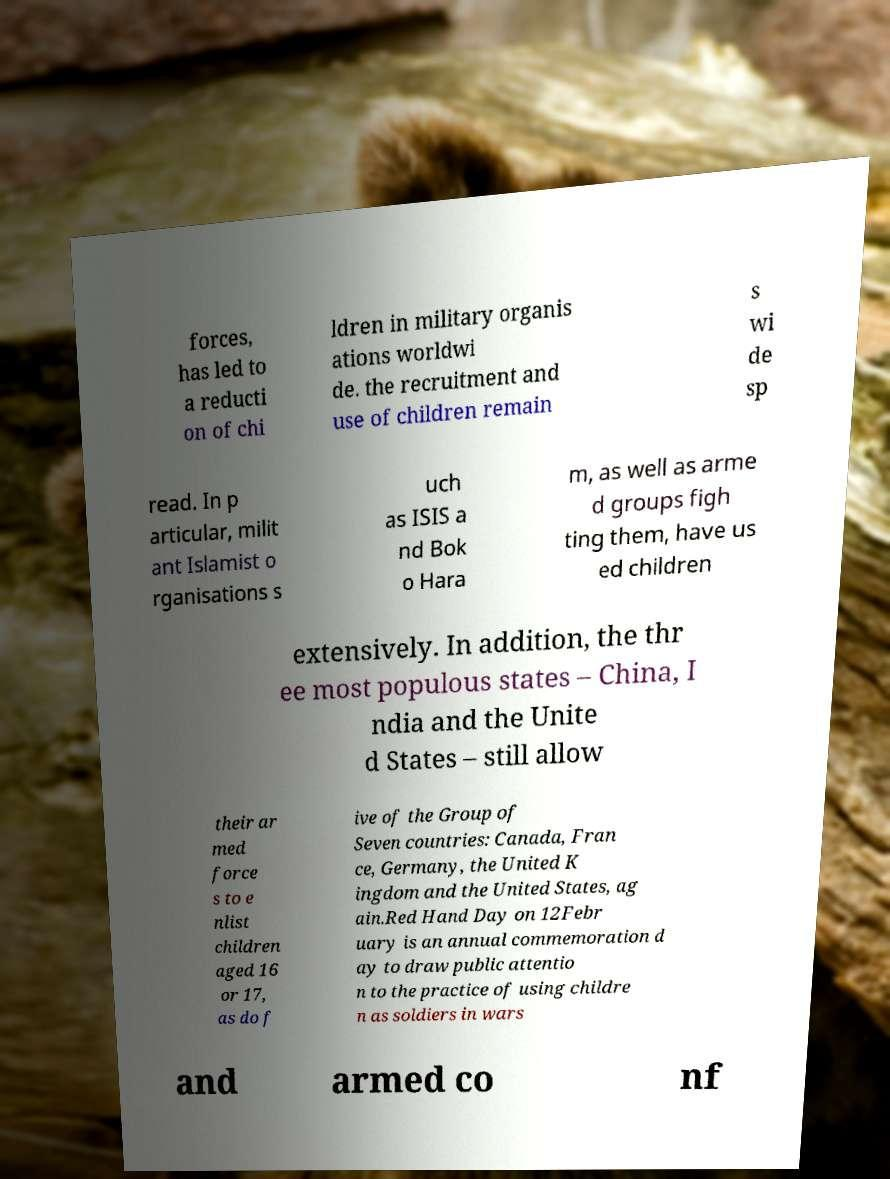Please read and relay the text visible in this image. What does it say? forces, has led to a reducti on of chi ldren in military organis ations worldwi de. the recruitment and use of children remain s wi de sp read. In p articular, milit ant Islamist o rganisations s uch as ISIS a nd Bok o Hara m, as well as arme d groups figh ting them, have us ed children extensively. In addition, the thr ee most populous states – China, I ndia and the Unite d States – still allow their ar med force s to e nlist children aged 16 or 17, as do f ive of the Group of Seven countries: Canada, Fran ce, Germany, the United K ingdom and the United States, ag ain.Red Hand Day on 12Febr uary is an annual commemoration d ay to draw public attentio n to the practice of using childre n as soldiers in wars and armed co nf 